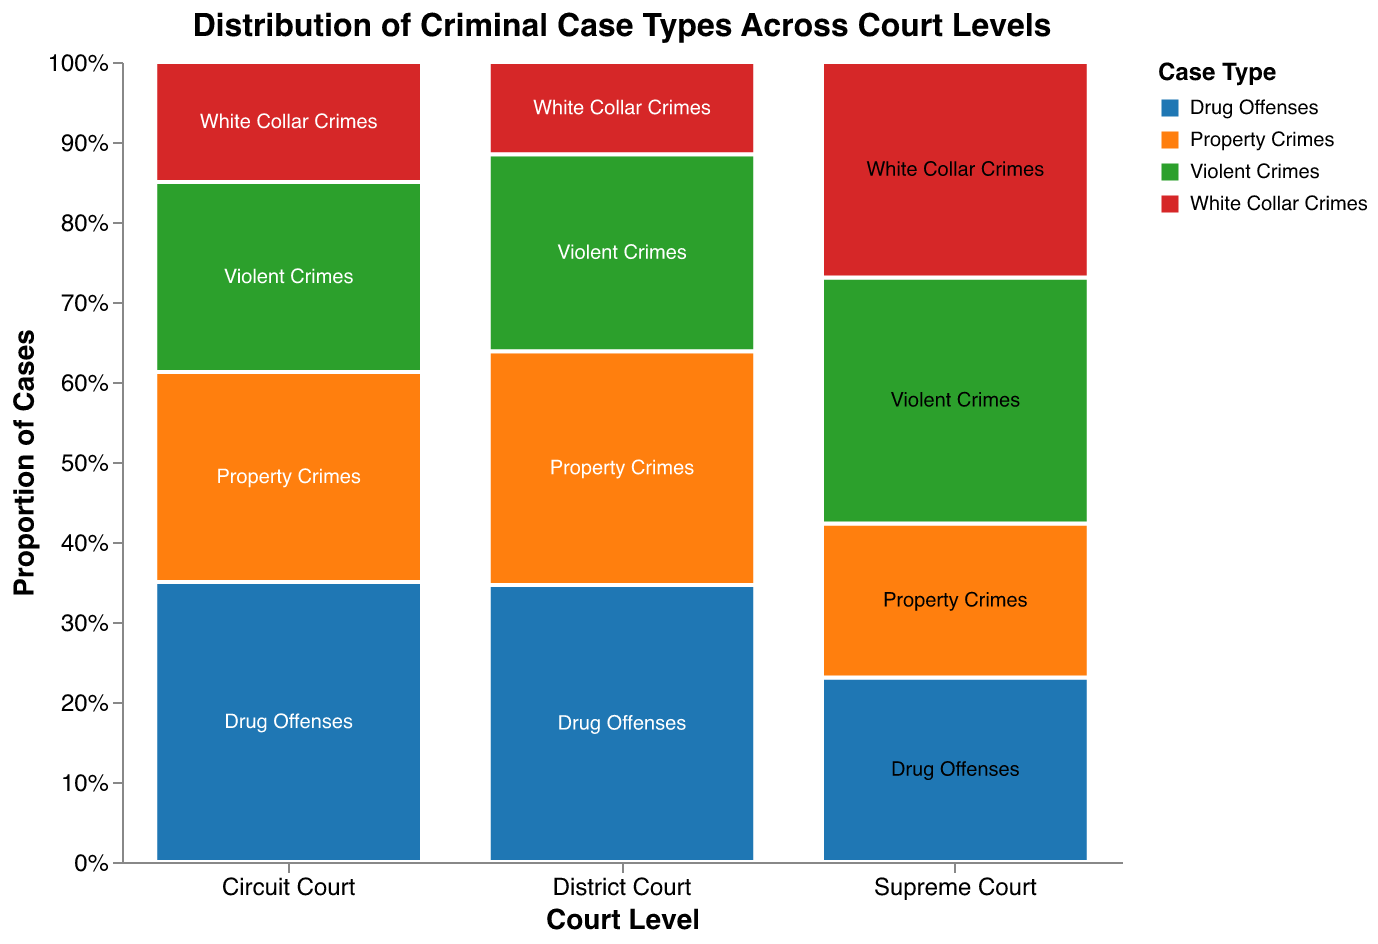What is the main title of the figure? The title is located at the top of the figure. It reads "Distribution of Criminal Case Types Across Court Levels".
Answer: Distribution of Criminal Case Types Across Court Levels Which Court Level has the most Drug Offenses cases? Observe the blocks representing Drug Offenses across all Court Levels. The tallest block in the "Drug Offenses" category is located in the District Court section.
Answer: District Court What is the proportion of Property Crimes cases in the Circuit Court? Look at the block representing Property Crimes within Circuit Court. The block size represents the proportion, and this block is roughly half the height of the Circuit Court area. Calculate it as 210 / (280 + 210 + 190 + 120) = 210 / 800 ≈ 0.2625, or approximately 26.25%.
Answer: 26.25% How many total cases are there in the Supreme Court? Sum all the counts for the Supreme Court: 30 (Drug Offenses) + 25 (Property Crimes) + 40 (Violent Crimes) + 35 (White Collar Crimes) = 130.
Answer: 130 Which Court Level has the smallest number of Violent Crimes cases? Look at the blocks for Violent Crimes across all Court Levels. The smallest block in this category is in the Supreme Court area.
Answer: Supreme Court What is the ratio of Drug Offenses to White Collar Crimes in the District Court? Calculate the ratio by dividing the count of Drug Offenses by the count of White Collar Crimes in the District Court: 450 / 150 = 3.
Answer: 3 How does the proportion of Violent Crimes compare between District Court and Circuit Court? Calculate the proportions of Violent Crimes for the District Court and Circuit Court. For District Court: 320 / (450 + 380 + 320 + 150) = 320 / 1300 ≈ 0.2462, or approximately 24.62%. For Circuit Court: 190 / (280 + 210 + 190 + 120) = 190 / 800 ≈ 0.2375, or approximately 23.75%. The proportion of Violent Crimes is slightly higher in District Court.
Answer: District Court slightly higher What is the median count of all case types in the Circuit Court? List the counts for Circuit Court (280, 210, 190, 120) in ascending order: 120, 190, 210, 280. The median is the average of the middle two numbers: (190 + 210) / 2 = 200.
Answer: 200 In which Court Level is the proportion of Drug Offenses the lowest? Calculate the proportion of Drug Offenses for each Court Level. For District Court: 450 / 1300 ≈ 34.62%. For Circuit Court: 280 / 800 ≈ 35%. For Supreme Court: 30 / 130 ≈ 23.08%. The lowest proportion is in the Supreme Court.
Answer: Supreme Court What case type comprises the largest proportion in the Supreme Court? Identify the tallest block within the Supreme Court section. The tallest block is representing Violent Crimes.
Answer: Violent Crimes 